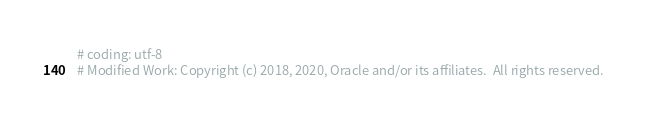<code> <loc_0><loc_0><loc_500><loc_500><_Python_># coding: utf-8
# Modified Work: Copyright (c) 2018, 2020, Oracle and/or its affiliates.  All rights reserved.</code> 